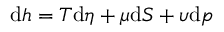<formula> <loc_0><loc_0><loc_500><loc_500>d h = T d \eta + \mu d S + \upsilon d p</formula> 